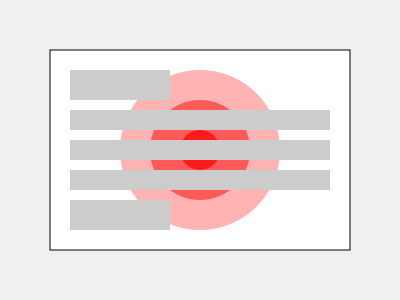Based on the eye-tracking heat map shown for a website layout, which area of the page appears to receive the most user attention, and what implications might this have for the emotional impact of the interface design? To analyze the eye-tracking heat map and its implications for emotional impact, let's follow these steps:

1. Interpret the heat map:
   - The red circles represent areas of user attention.
   - The intensity of the red color indicates the level of attention (more intense = more attention).
   - The largest, most intense red area is at the center of the page.

2. Identify the most attended area:
   - The center of the page receives the most attention, as indicated by the darkest red circle.

3. Analyze the layout:
   - The center area likely contains the main content or a key visual element.
   - Surrounding gray rectangles represent other page elements (e.g., text, buttons, images).

4. Consider cognitive science principles:
   - Central fixation: Users tend to focus on the center of the screen first.
   - Visual saliency: The central element draws and holds attention.

5. Evaluate emotional impact:
   - High attention to the central area may indicate user engagement.
   - The clear focus point could reduce cognitive load, potentially leading to a more positive emotional experience.
   - However, the lack of attention to other areas might mean important information is being overlooked.

6. Implications for interface design:
   - Place the most critical or emotionally impactful content in the center.
   - Consider redistributing some elements to create a more balanced attention pattern.
   - Use the central area to set the emotional tone for the entire page.

7. Potential improvements:
   - Introduce secondary focal points to guide users to other important areas.
   - Ensure that the central element aligns with the desired emotional response.
   - Consider using color or contrast to draw attention to other key areas without compromising the central focus.
Answer: The center receives most attention; implies strong emotional impact of central content, potential for user engagement, but possible neglect of peripheral information. 